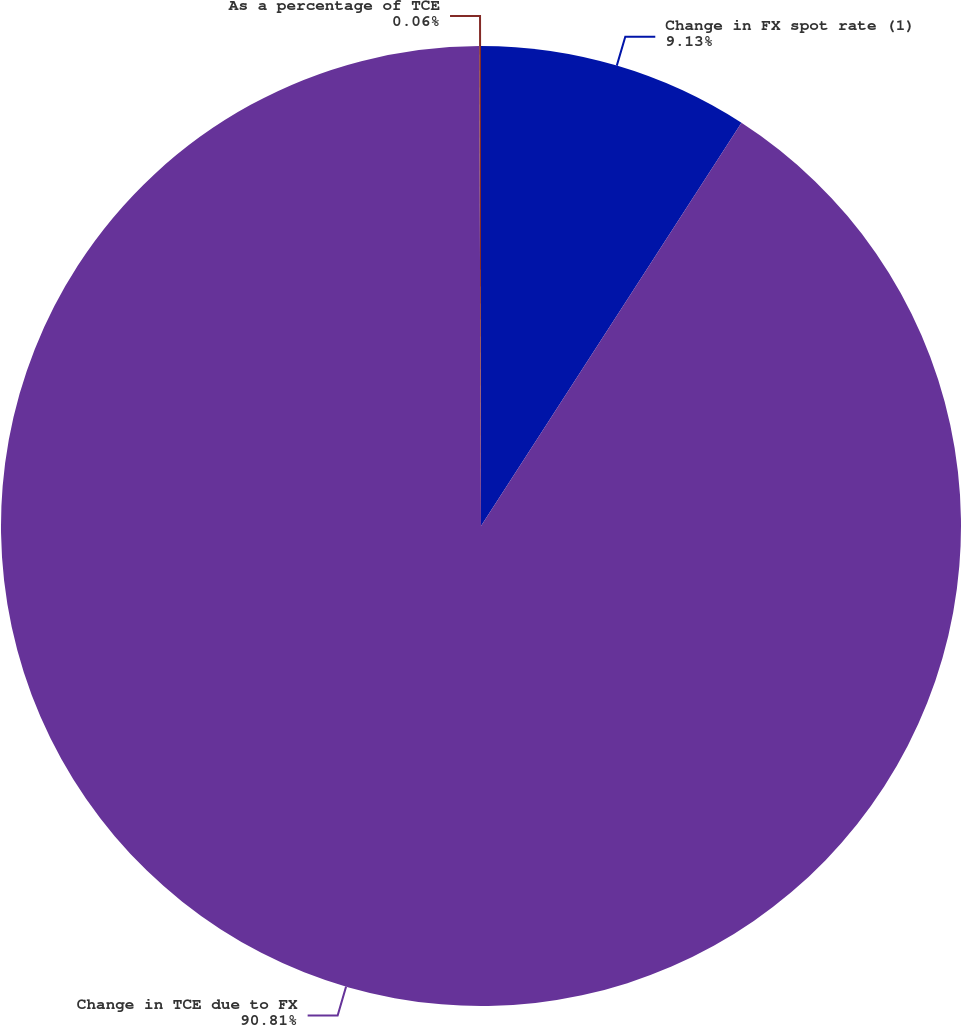Convert chart to OTSL. <chart><loc_0><loc_0><loc_500><loc_500><pie_chart><fcel>Change in FX spot rate (1)<fcel>Change in TCE due to FX<fcel>As a percentage of TCE<nl><fcel>9.13%<fcel>90.81%<fcel>0.06%<nl></chart> 